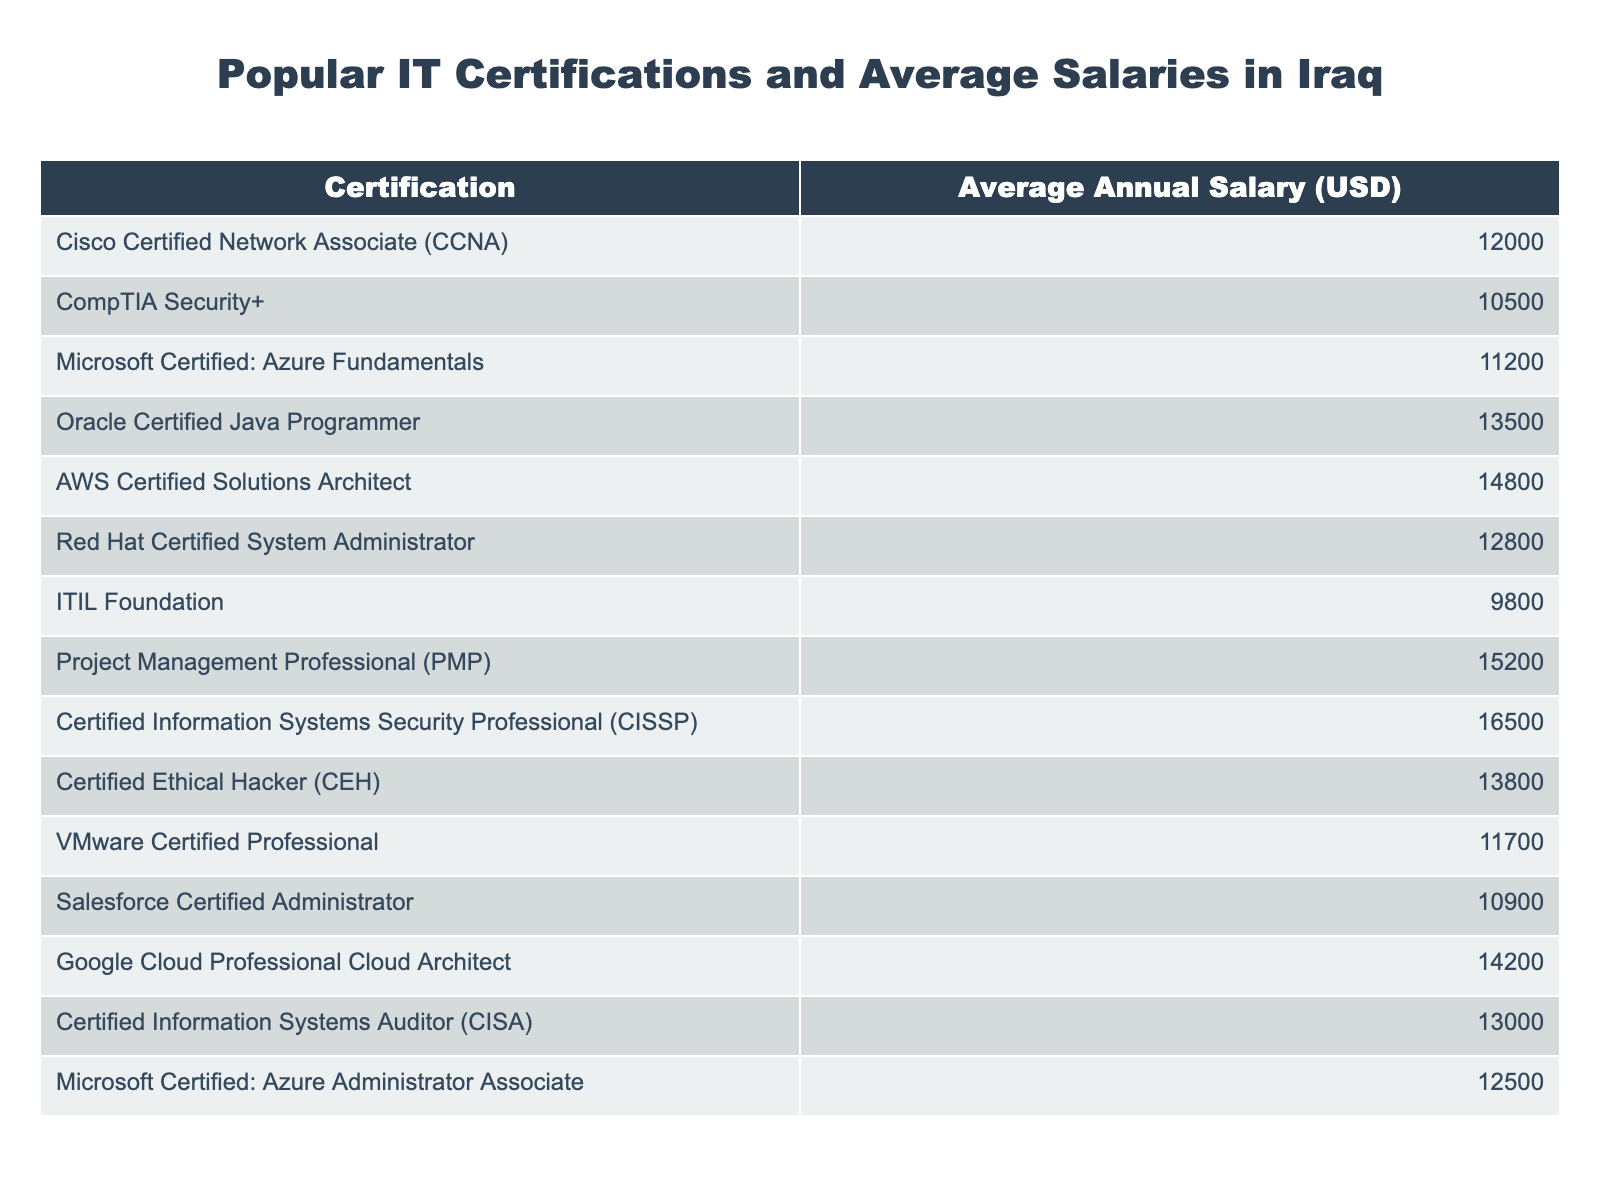What is the average annual salary for a Cisco Certified Network Associate (CCNA)? Looking at the table, the average annual salary for a CCNA is listed directly, which is 12000 USD.
Answer: 12000 USD Which certification has the highest average salary? By scanning through the average salaries in the table, the certification with the highest average salary is the Certified Information Systems Security Professional (CISSP) at 16500 USD.
Answer: Certified Information Systems Security Professional (CISSP) Is the average salary for AWS Certified Solutions Architect higher than 14000 USD? Checking the table, the average salary for AWS Certified Solutions Architect is 14800 USD, which is indeed higher than 14000 USD.
Answer: Yes What is the difference in average salaries between the Certified Ethical Hacker (CEH) and the CompTIA Security+? The average salary for CEH is 13800 USD and for CompTIA Security+ it is 10500 USD. The difference is 13800 - 10500 = 3300 USD.
Answer: 3300 USD What is the average salary of the four highest paying certifications? The four highest paying certifications are: Certified Information Systems Security Professional (CISSP) - 16500 USD, Project Management Professional (PMP) - 15200 USD, AWS Certified Solutions Architect - 14800 USD, and Google Cloud Professional Cloud Architect - 14200 USD. Adding these together: 16500 + 15200 + 14800 + 14200 = 60700 USD. Dividing by 4 gives an average of 60700 / 4 = 15175 USD.
Answer: 15175 USD Which certification earns less: ITIL Foundation or Microsoft Certified: Azure Fundamentals? The table shows that ITIL Foundation has an average salary of 9800 USD and Microsoft Certified: Azure Fundamentals has 11200 USD, therefore ITIL Foundation earns less.
Answer: ITIL Foundation Is obtaining a Red Hat Certified System Administrator certification likely to provide a higher salary than a VMware Certified Professional certification? The average salary for a Red Hat Certified System Administrator is 12800 USD, while for VMware Certified Professional it is 11700 USD. Therefore, Red Hat certification offers a higher salary.
Answer: Yes If someone is considering between Salesforce Certified Administrator and Microsoft Certified: Azure Administrator Associate, which certification offers a better average salary? The average salary for Salesforce Certified Administrator is 10900 USD, and for Microsoft Certified: Azure Administrator Associate it is 12500 USD. Comparing these two values shows that the Microsoft certification offers a better average salary.
Answer: Microsoft Certified: Azure Administrator Associate 